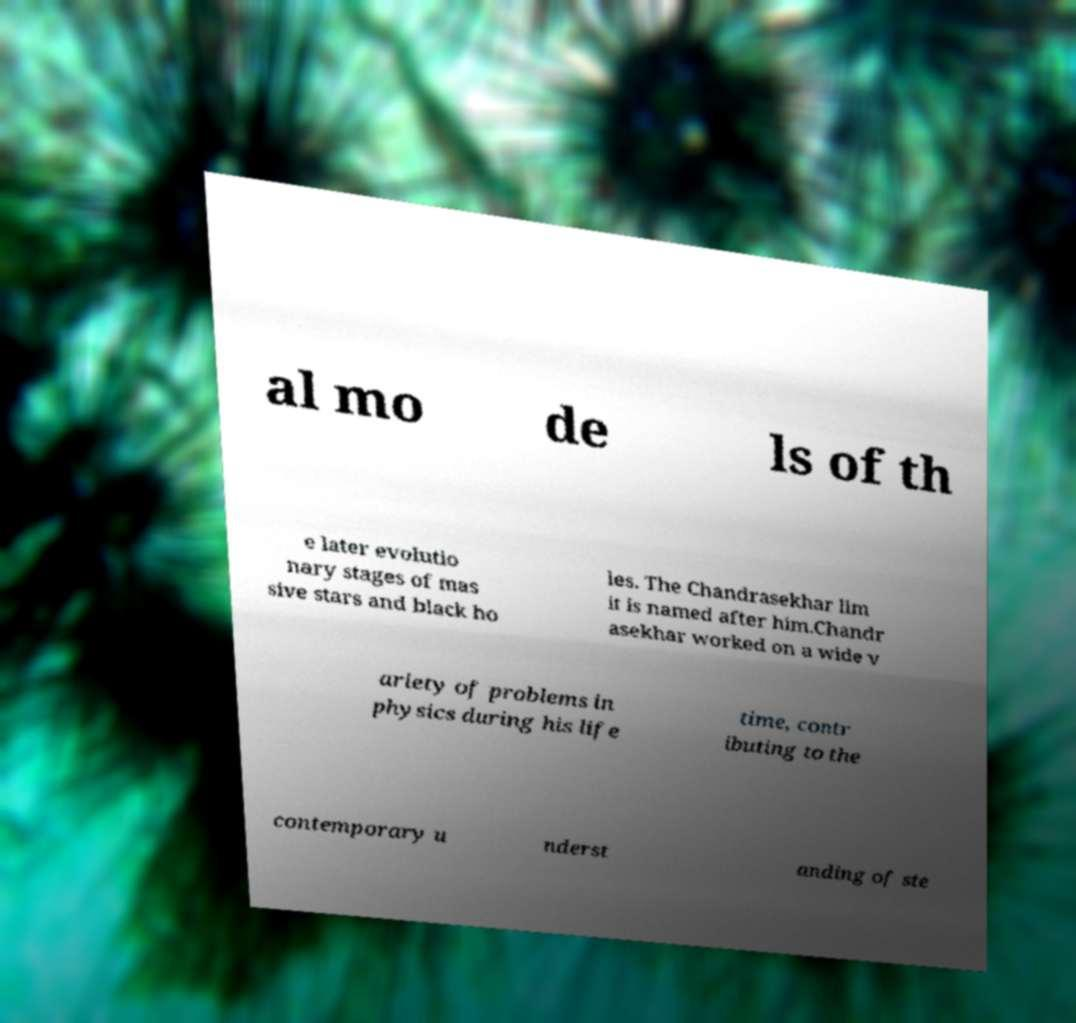Please read and relay the text visible in this image. What does it say? al mo de ls of th e later evolutio nary stages of mas sive stars and black ho les. The Chandrasekhar lim it is named after him.Chandr asekhar worked on a wide v ariety of problems in physics during his life time, contr ibuting to the contemporary u nderst anding of ste 